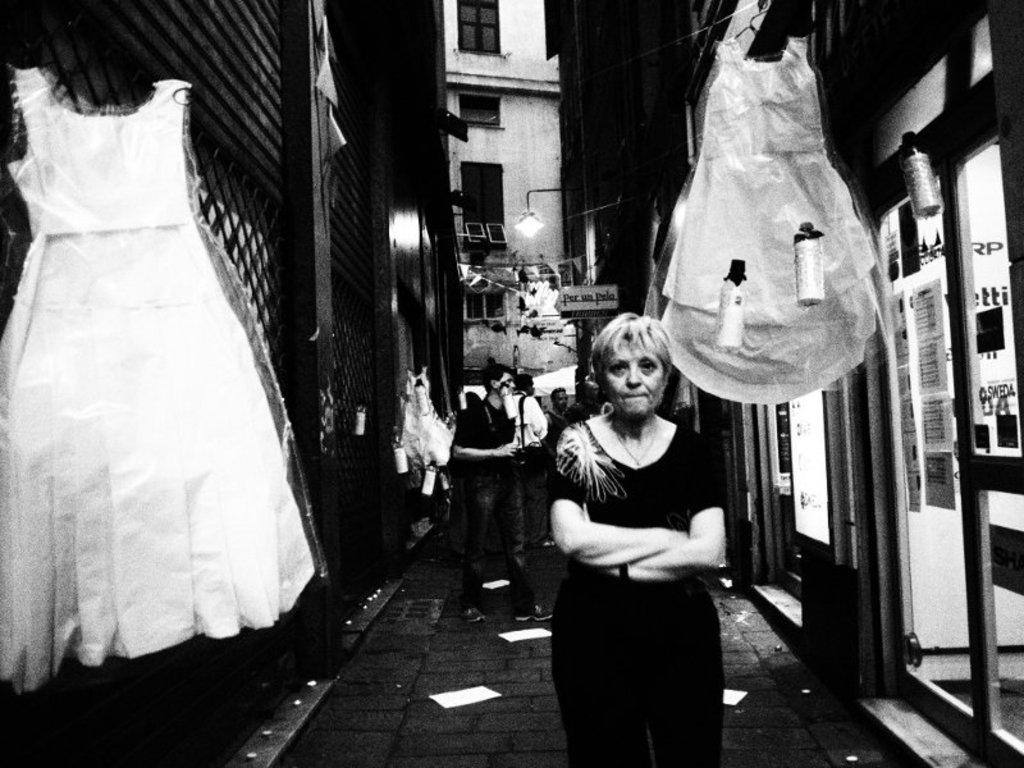What is the color scheme of the image? The image is black and white. What can be seen on the pavement in the image? There are people standing on the pavement in the image. What type of establishments are located near the pavement? There are shops on either side of the pavement. Can you see an oven in the image? There is no oven present in the image. Is there a river visible in the image? The image does not show any river; it features people standing on a pavement with shops on either side. 